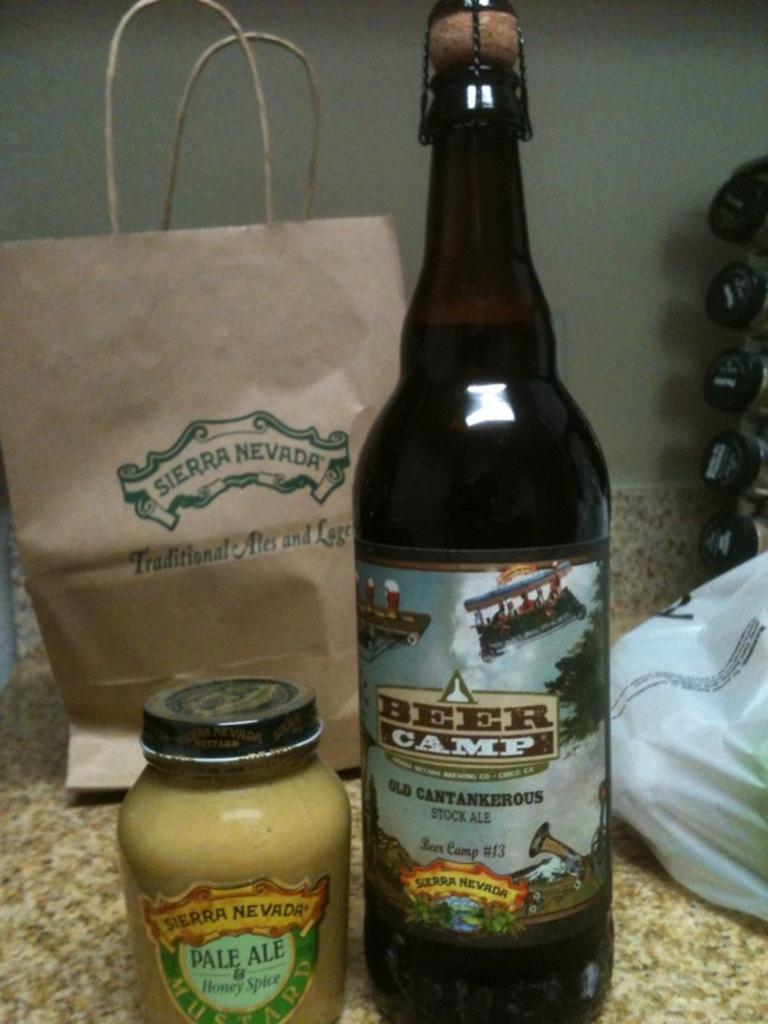<image>
Relay a brief, clear account of the picture shown. Some items on a counter include a beer and a bag from Sierra Nevada. 